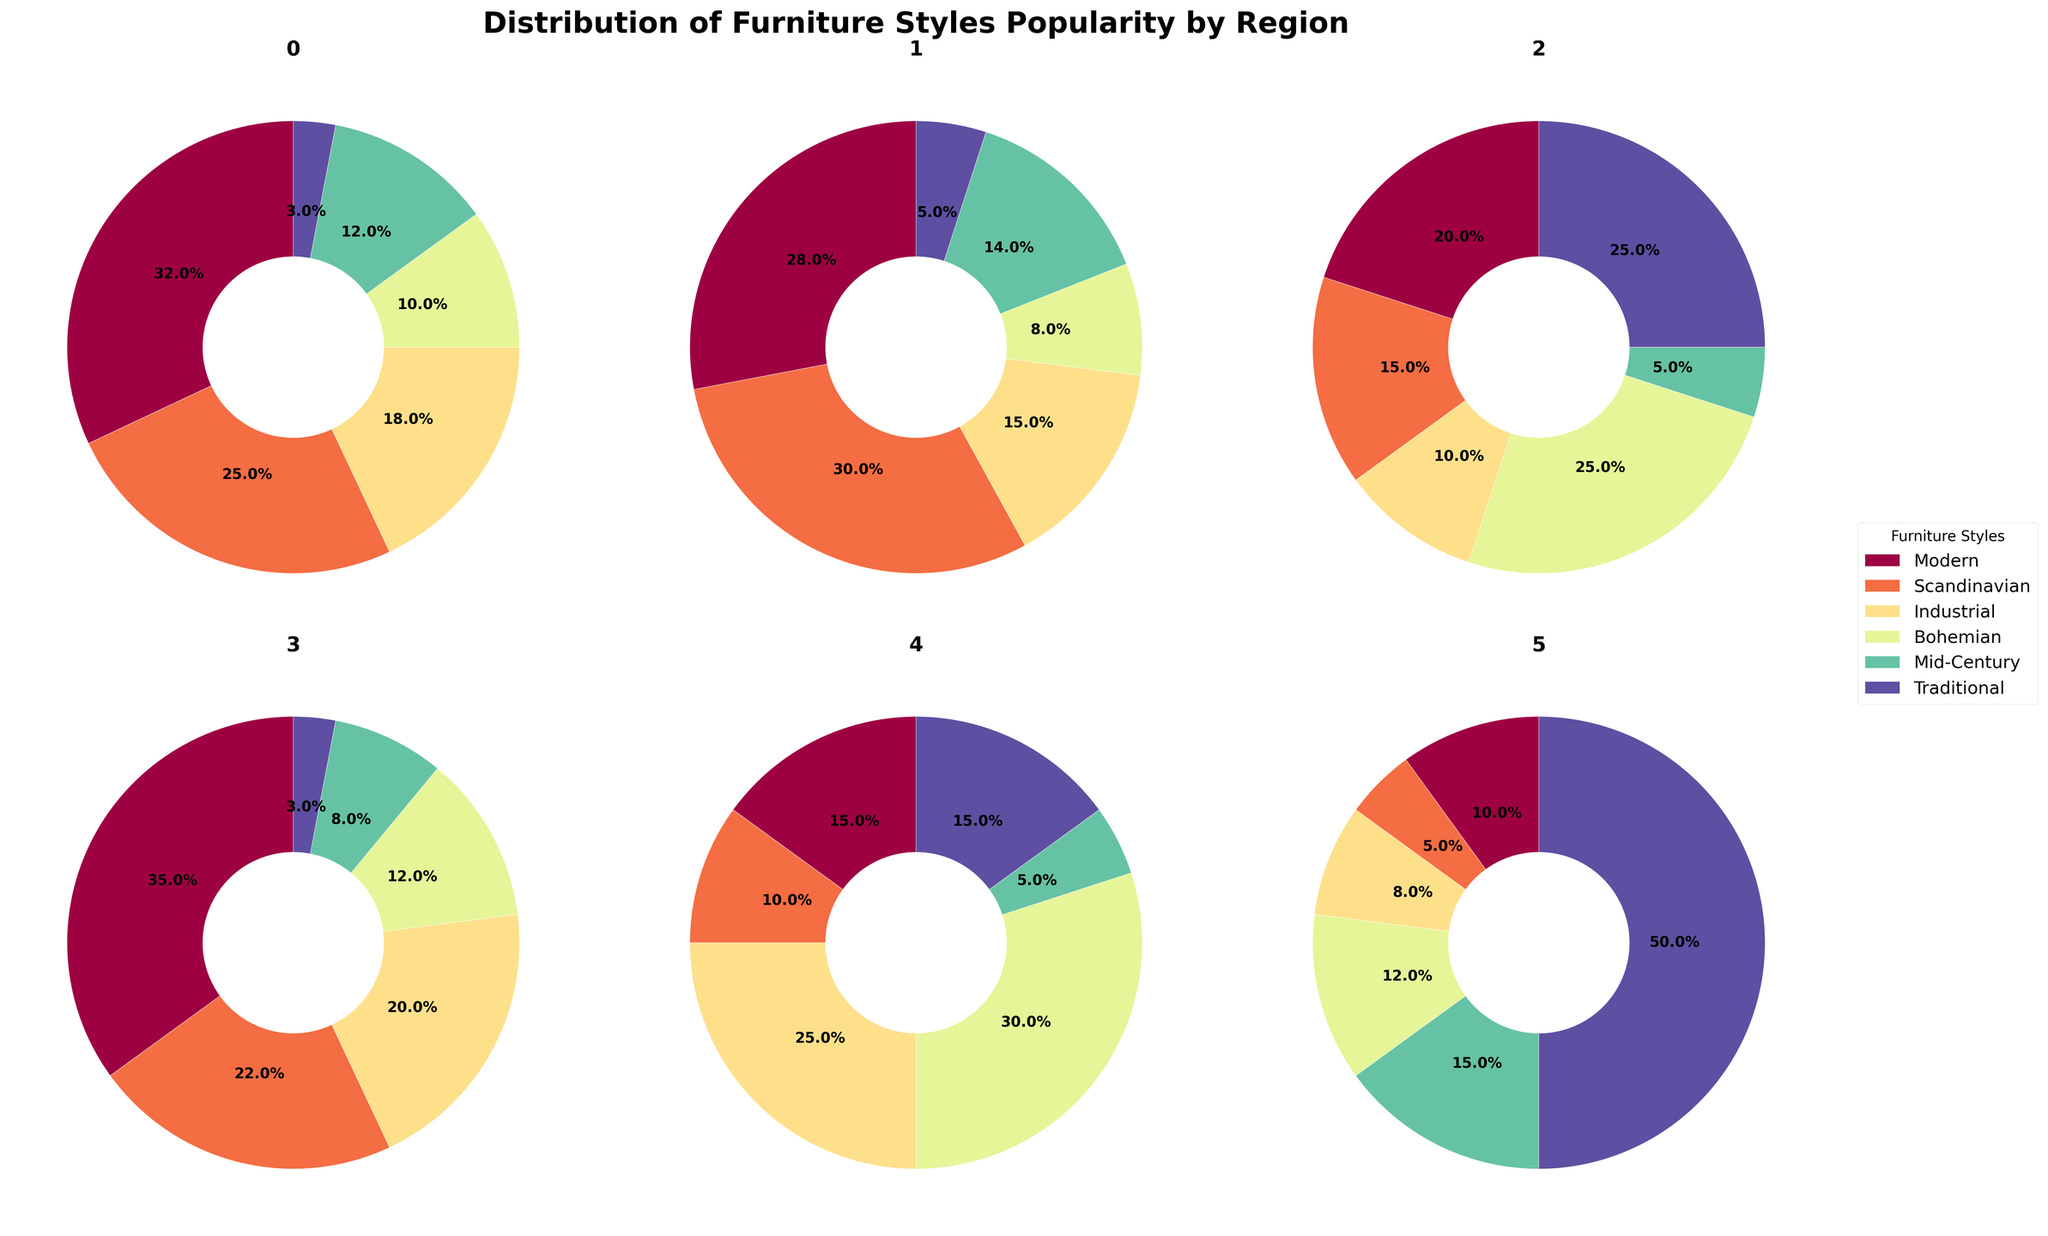Which region has the highest percentage of Traditional furniture styles? The pie charts show the distribution of furniture styles across different regions. By inspecting the slices labeled 'Traditional', we see that the Middle East has the largest slice dedicated to 'Traditional' styles, indicating the highest percentage.
Answer: Middle East What percentage of Mid-Century styles is popular in Africa? By examining the pie charts, we do not see Africa represented in the data, so this information is not available.
Answer: Not available How many regions have Modern as the most popular style? By inspecting each pie chart for the largest slice, we see that North America, Australia, and Europe have 'Modern' as the most significant section, totaling to 3 regions.
Answer: 3 Which region shows the least popularity for Scandinavian styles? By comparing the 'Scandinavian' slices, the Middle East has the smallest slice, indicating the least popularity for this style.
Answer: Middle East What percentage does Scandinavian style constitute in Europe? By examining the Europe pie chart, we see that the 'Scandinavian' style slice is labeled as 30.0%.
Answer: 30.0% Which two regions share the same percentage for Mid-Century styles? By inspecting the pie charts, we see that North America and South America both have a 5% slice for 'Mid-Century' styles.
Answer: North America and South America What is the combined percentage of Industrial and Bohemian styles in South America? In the South America pie chart, 'Industrial' is 25% and 'Bohemian' is 30%. Adding them together, we get 25% + 30% = 55%.
Answer: 55% In which region is Bohemian furniture style the most popular? By looking at the slices labeled 'Bohemian' in each pie chart, South America has the largest slice, indicating that Bohemian is most popular there.
Answer: South America Which region has the widest gap between the most and least popular furniture styles? By checking the slices for the most and least popular styles in each region, the Middle East has the widest gap, with 'Traditional' at 50% and 'Scandinavian' at 5%, resulting in a 45% gap.
Answer: Middle East What are all the furniture styles that have over 20% popularity in North America? In the pie chart for North America, 'Modern' has 32%, 'Scandinavian' has 25%, and 'Industrial' has 18%. Only 'Modern' and 'Scandinavian' exceed 20%.
Answer: Modern and Scandinavian 